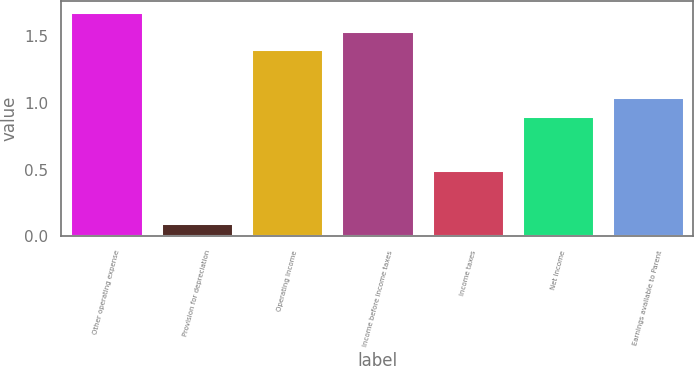Convert chart. <chart><loc_0><loc_0><loc_500><loc_500><bar_chart><fcel>Other operating expense<fcel>Provision for depreciation<fcel>Operating Income<fcel>Income before income taxes<fcel>Income taxes<fcel>Net Income<fcel>Earnings available to Parent<nl><fcel>1.68<fcel>0.1<fcel>1.4<fcel>1.54<fcel>0.5<fcel>0.9<fcel>1.04<nl></chart> 